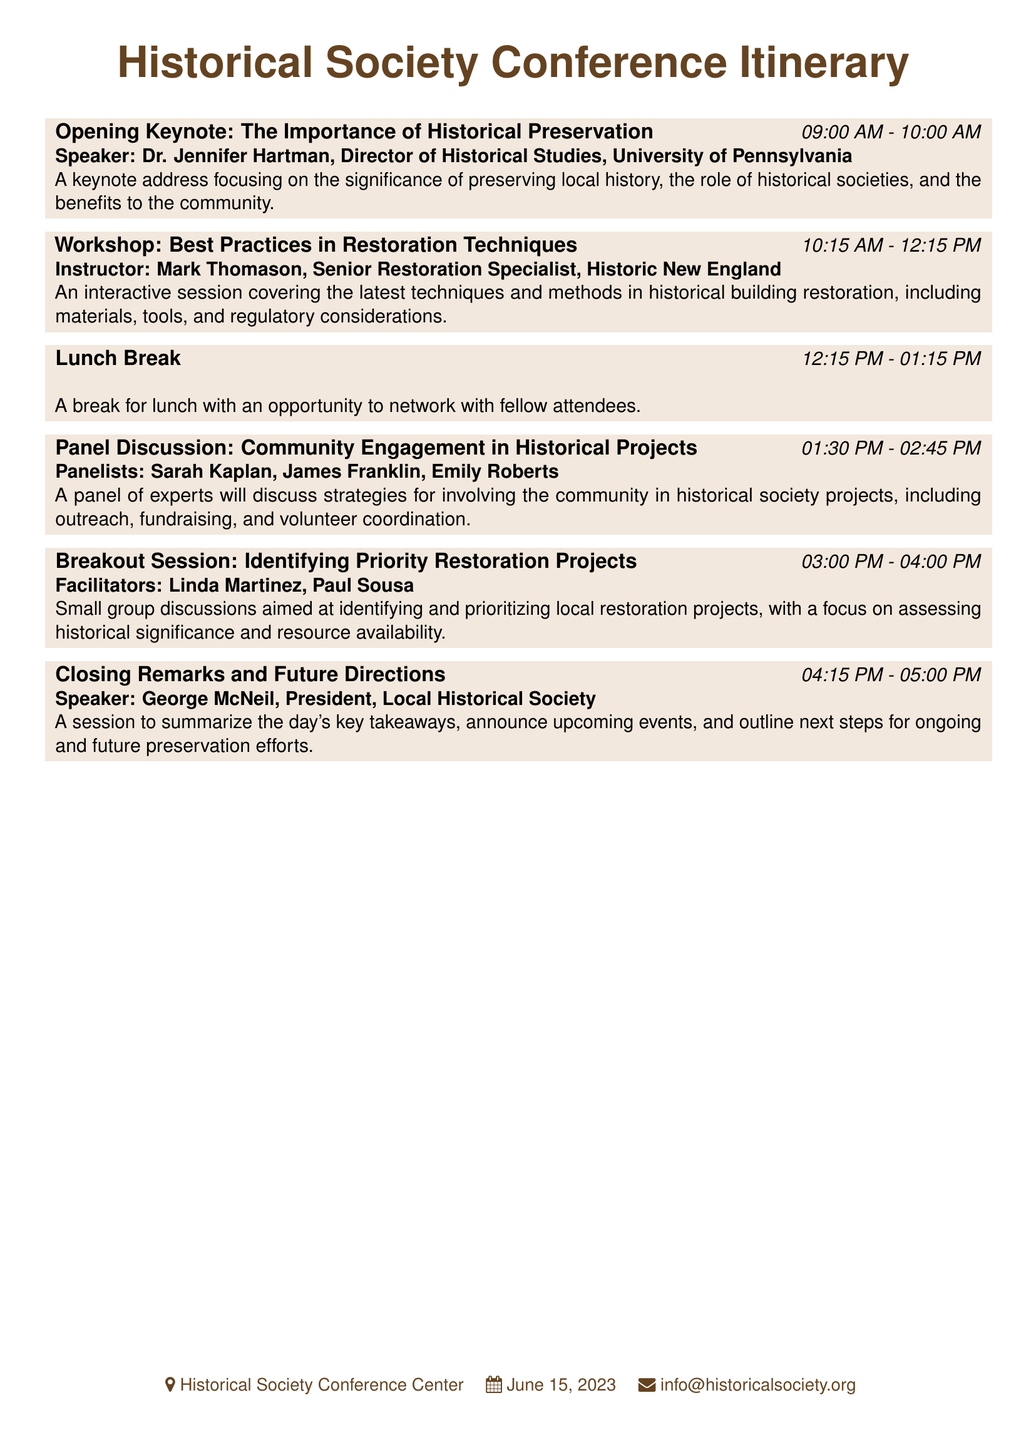What is the title of the opening keynote? The title of the opening keynote is the first event item in the document, which addresses the importance of historical preservation.
Answer: The Importance of Historical Preservation Who is the speaker for the workshop on restoration techniques? The workshop is led by the instructor mentioned in the document, which specifically states his name and title.
Answer: Mark Thomason What time does the lunch break start? The lunch break is noted in the document with specific timing clearly mentioned for that event.
Answer: 12:15 PM What is the focus of the breakout session? The breakout session is described in the document and reveals its aim regarding restoration projects.
Answer: Identifying and prioritizing local restoration projects When will the conference take place? The date of the conference is mentioned at the bottom of the document as a key temporal detail.
Answer: June 15, 2023 Who are the panelists for the community engagement discussion? The panelists are listed explicitly in the document as part of the panel discussion item.
Answer: Sarah Kaplan, James Franklin, Emily Roberts What are the closing remarks about? The content of the closing remarks is outlined in the document, summarizing key points and future events.
Answer: Summary of the day's key takeaways, upcoming events, and next steps What type of room is the conference held in? The location is detailed at the end of the document, indicating where the event is taking place.
Answer: Historical Society Conference Center 